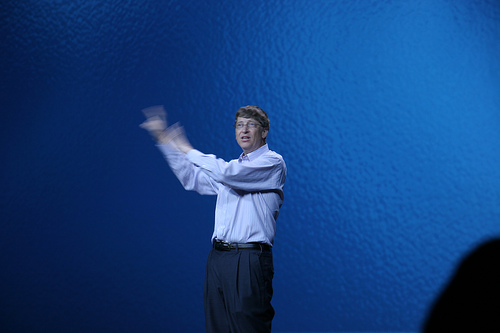<image>
Is the man in front of the wall? Yes. The man is positioned in front of the wall, appearing closer to the camera viewpoint. 